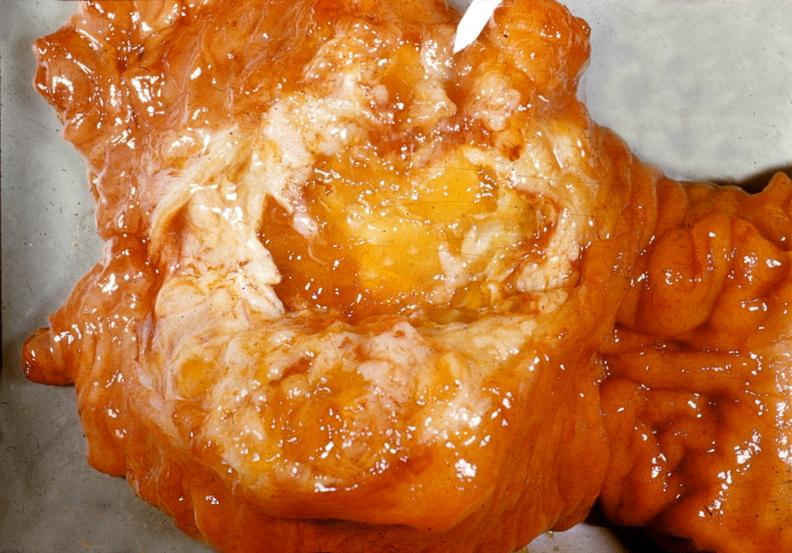does excellent vertebral body primary show adenocarcinoma, mucinous, head of pancreas?
Answer the question using a single word or phrase. No 